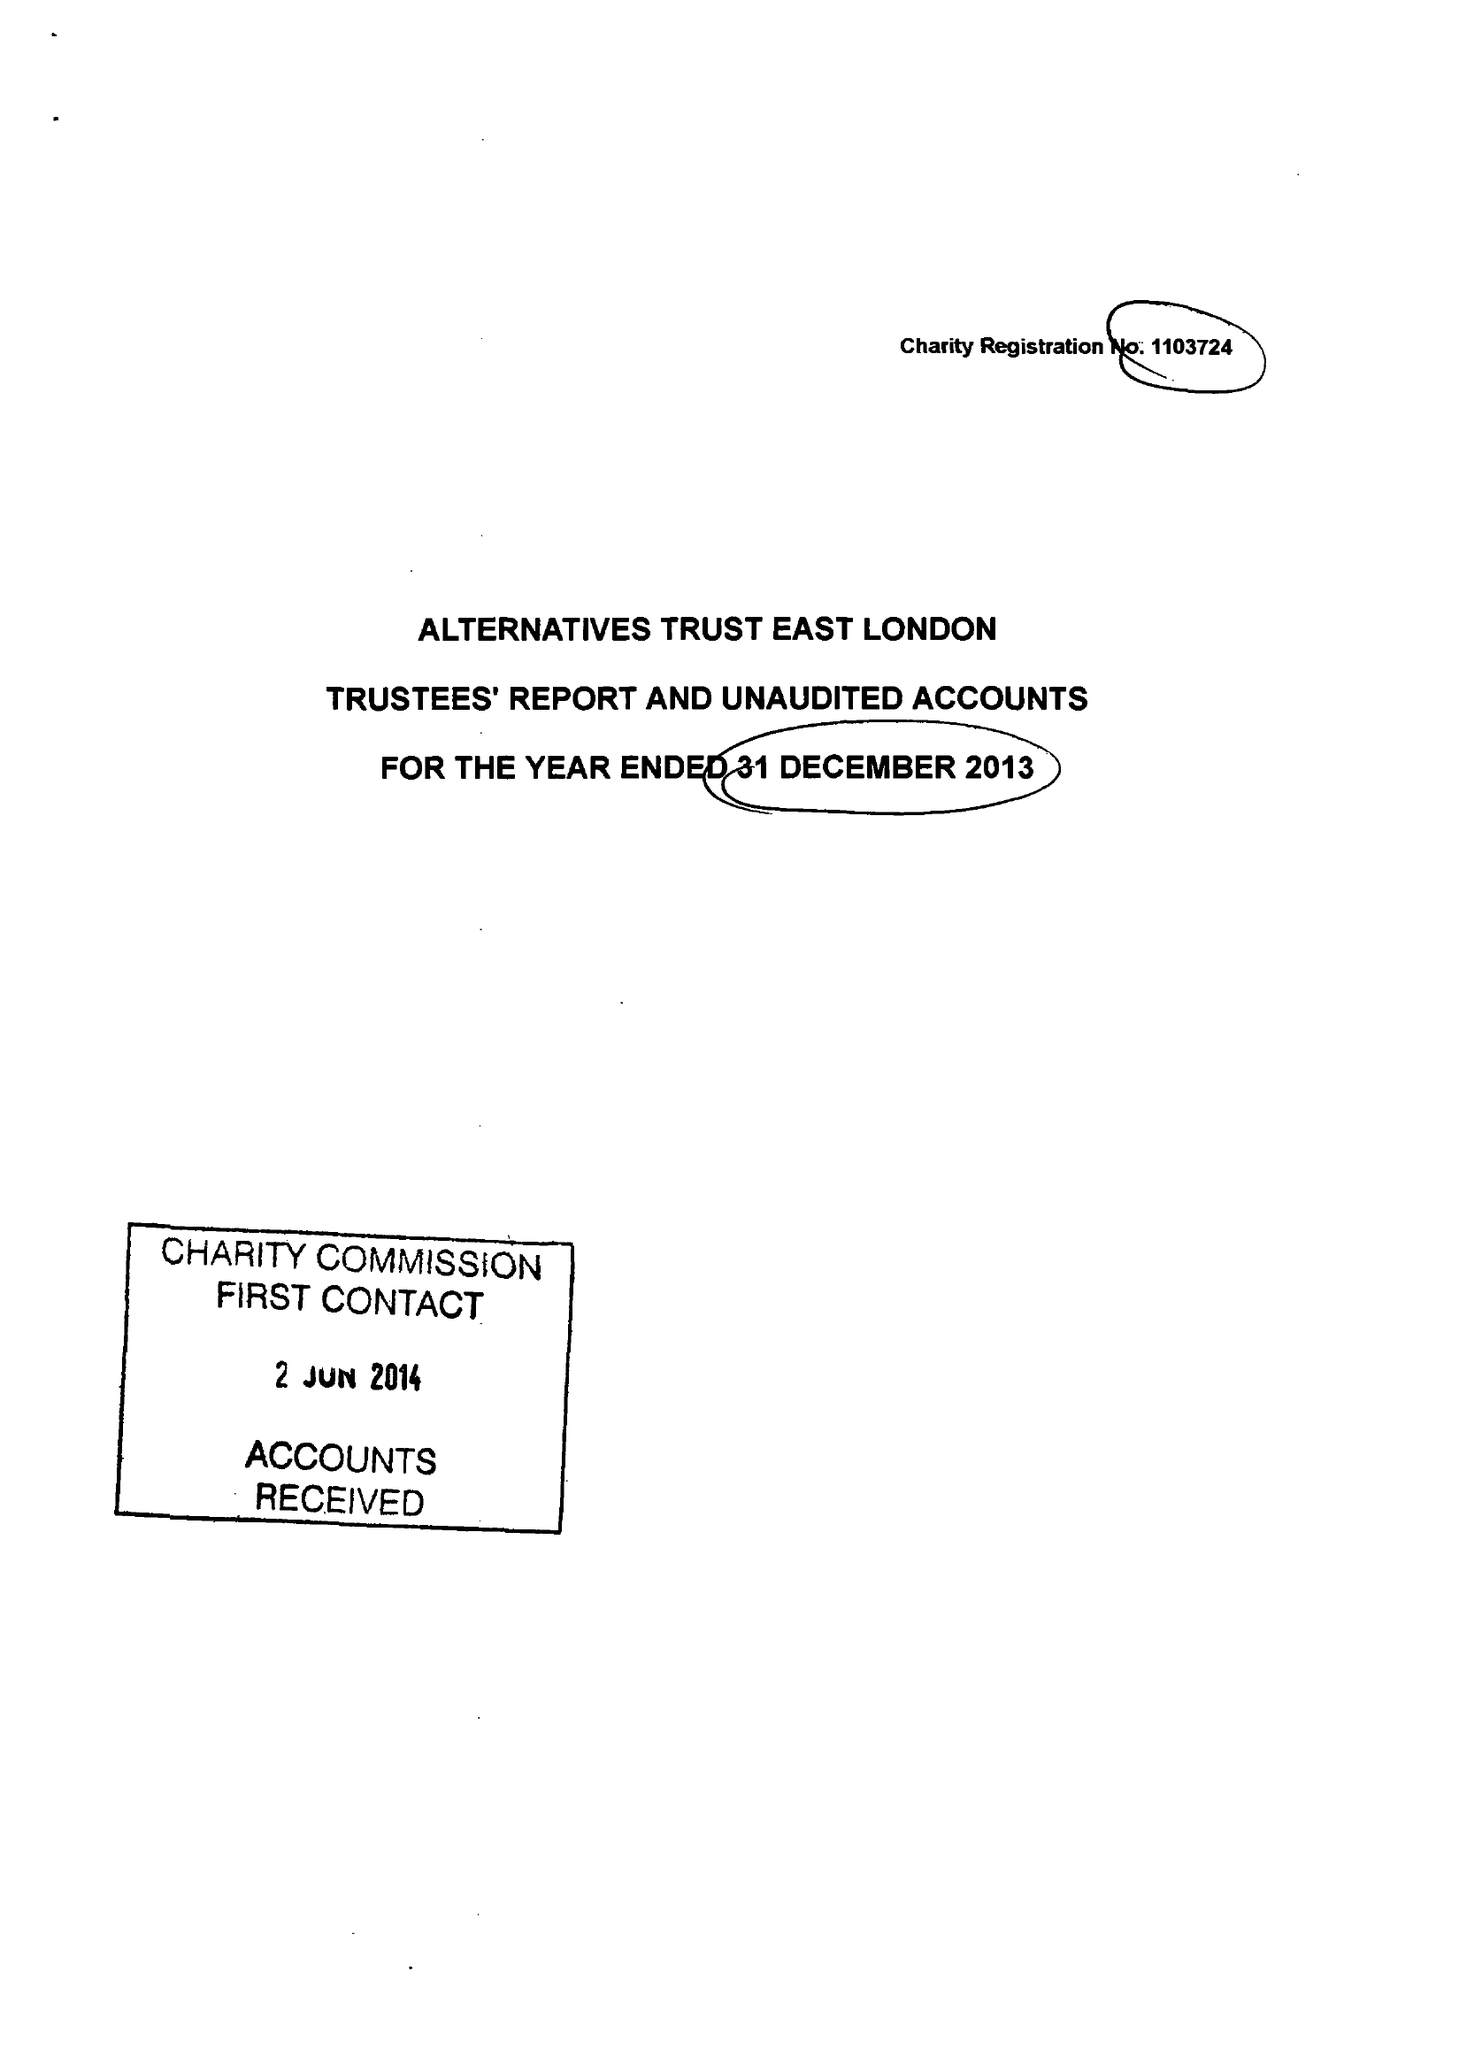What is the value for the address__street_line?
Answer the question using a single word or phrase. 63 ROWNTREE CLIFFORD CLOSE 